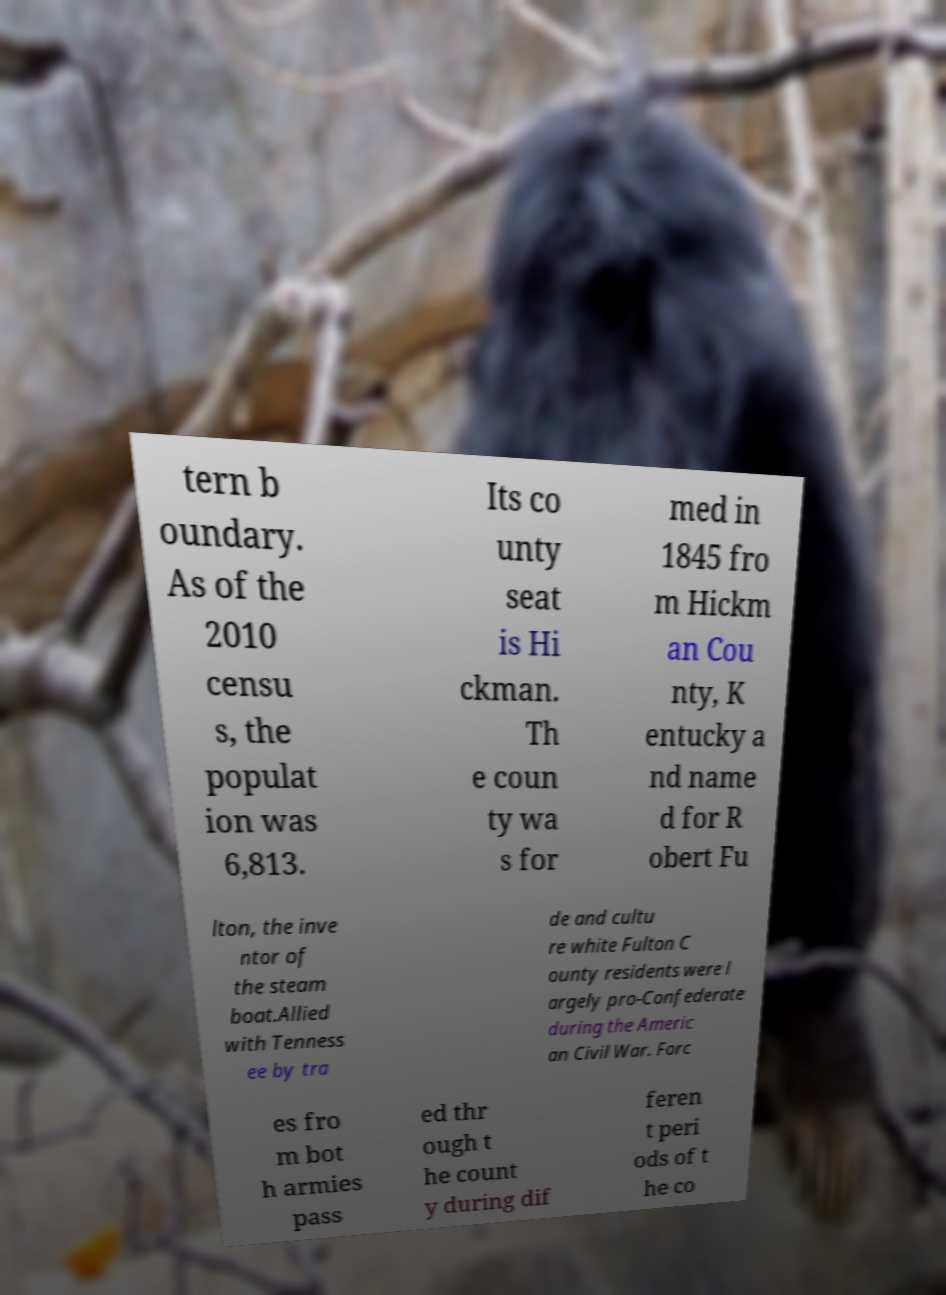Could you assist in decoding the text presented in this image and type it out clearly? tern b oundary. As of the 2010 censu s, the populat ion was 6,813. Its co unty seat is Hi ckman. Th e coun ty wa s for med in 1845 fro m Hickm an Cou nty, K entucky a nd name d for R obert Fu lton, the inve ntor of the steam boat.Allied with Tenness ee by tra de and cultu re white Fulton C ounty residents were l argely pro-Confederate during the Americ an Civil War. Forc es fro m bot h armies pass ed thr ough t he count y during dif feren t peri ods of t he co 